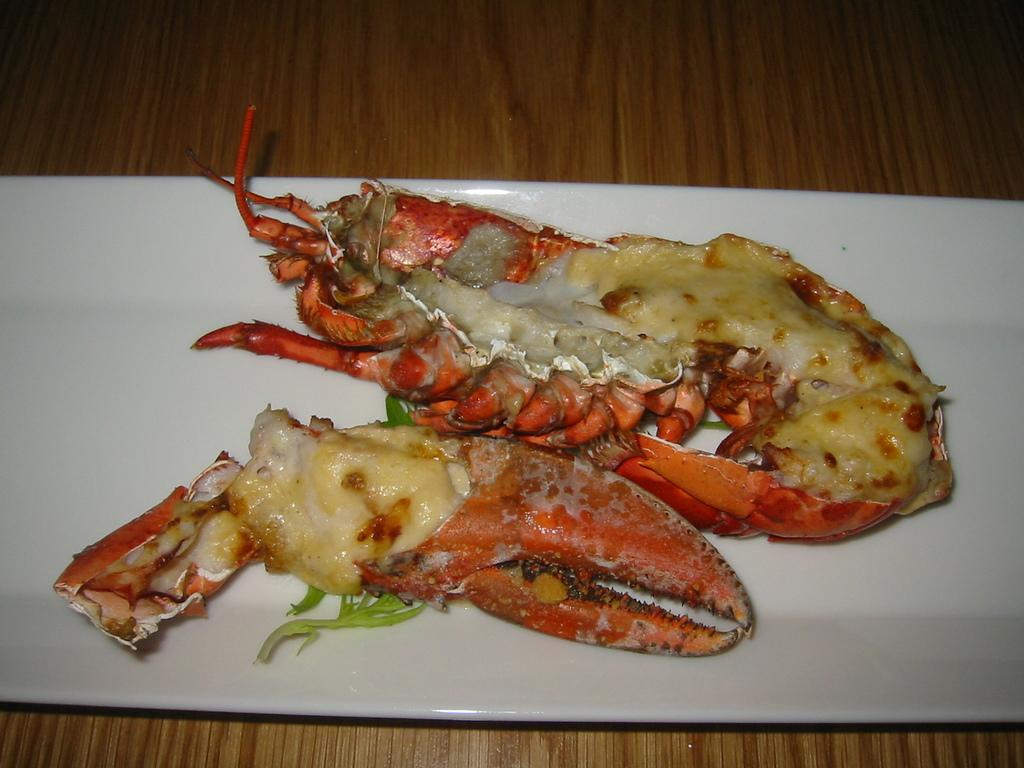What is the main food item visible in the image? There is a food item served in a plate in the image. Where is the plate with the food item located? The plate is on a table. What type of honey is being used to caption the image? There is no honey or caption present in the image. 